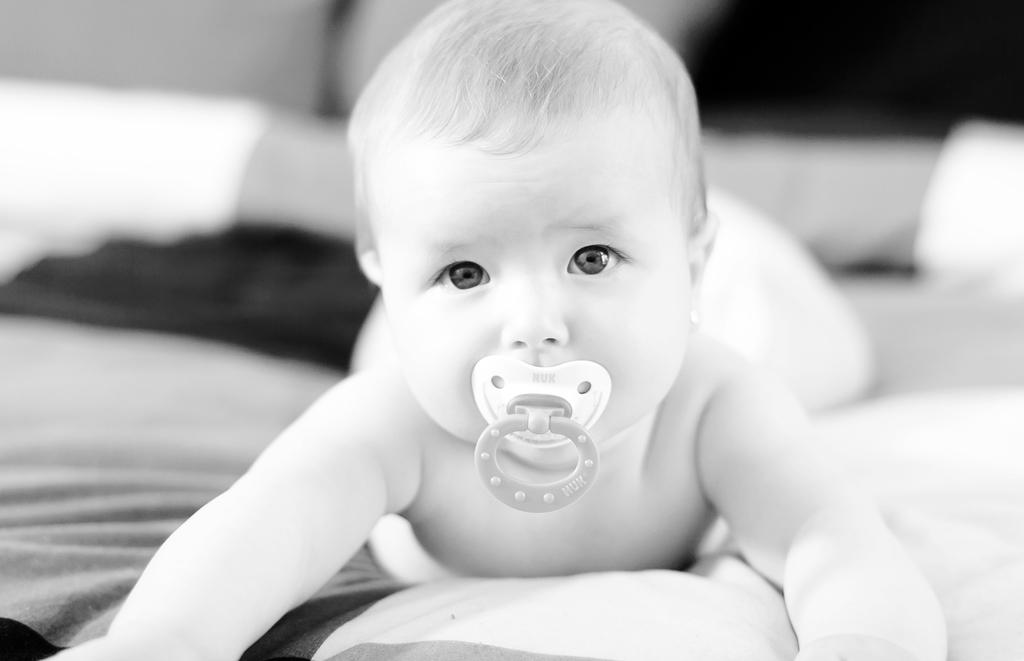What is the main subject of the image? There is a baby lying in the image. What else can be seen in the image besides the baby? There is a cloth and a baby sucker in the image. What type of teeth can be seen in the image? There are no teeth visible in the image, as it features a baby lying down. What is the baby doing with the turkey in the image? There is no turkey present in the image; it only shows a baby, a cloth, and a baby sucker. 